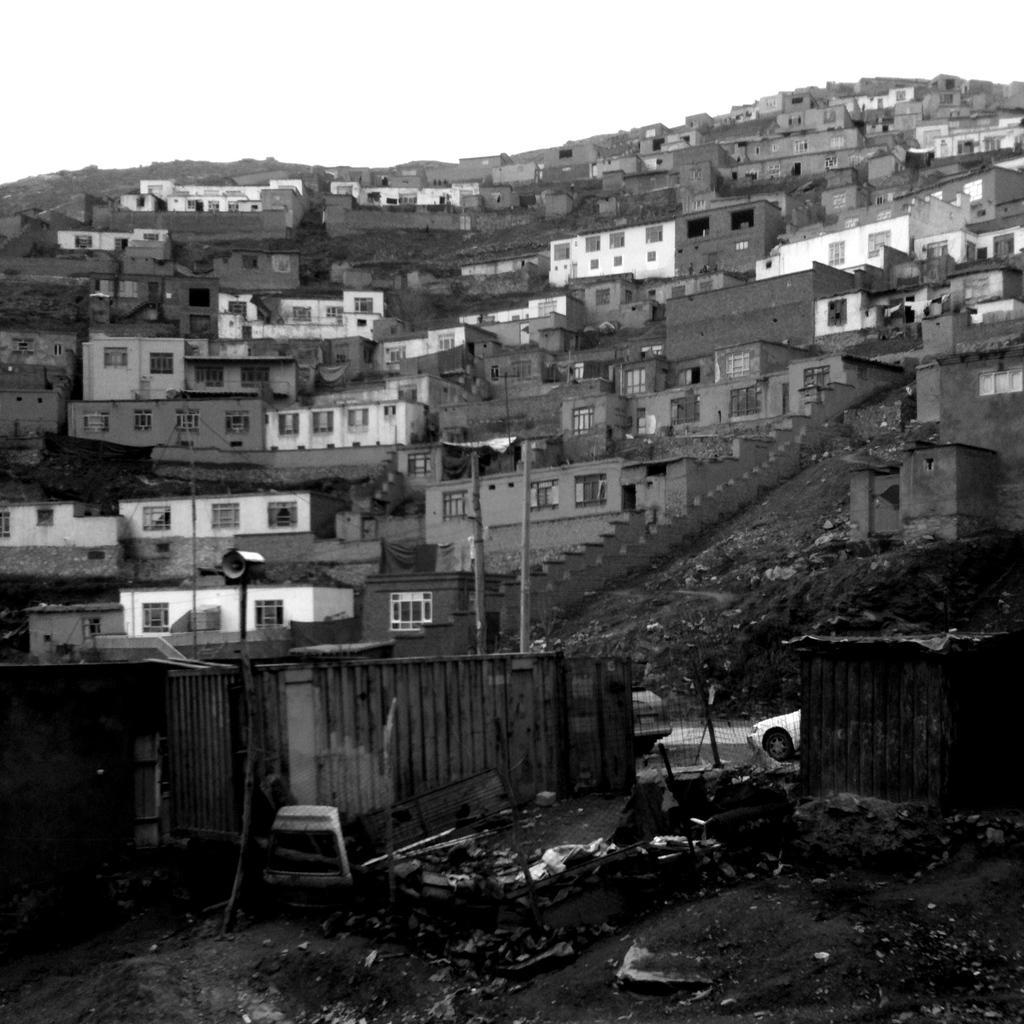Could you give a brief overview of what you see in this image? This image is a black and white image. This image is taken outdoors. At the bottom of the image there is a ground. In the middle of the image there are many houses with walls, windows, doors and roofs. There are a few stairs. There are a few poles. There are a few iron sheets. Two cars are parked on the road. 